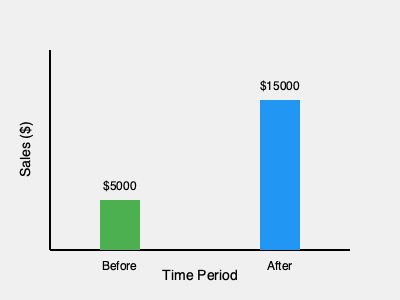As a shop owner, you implemented a new marketing campaign to boost sales. The chart shows your shop's sales before and after the campaign. What was the percentage increase in sales after the campaign? To calculate the percentage increase in sales, we'll follow these steps:

1. Identify the sales figures:
   - Before the campaign: $5000
   - After the campaign: $15000

2. Calculate the difference in sales:
   $15000 - $5000 = $10000

3. Calculate the percentage increase using the formula:
   Percentage increase = (Increase / Original Amount) × 100

   In this case:
   Percentage increase = ($10000 / $5000) × 100

4. Solve the equation:
   Percentage increase = 2 × 100 = 200%

Therefore, the sales increased by 200% after the marketing campaign.
Answer: 200% 